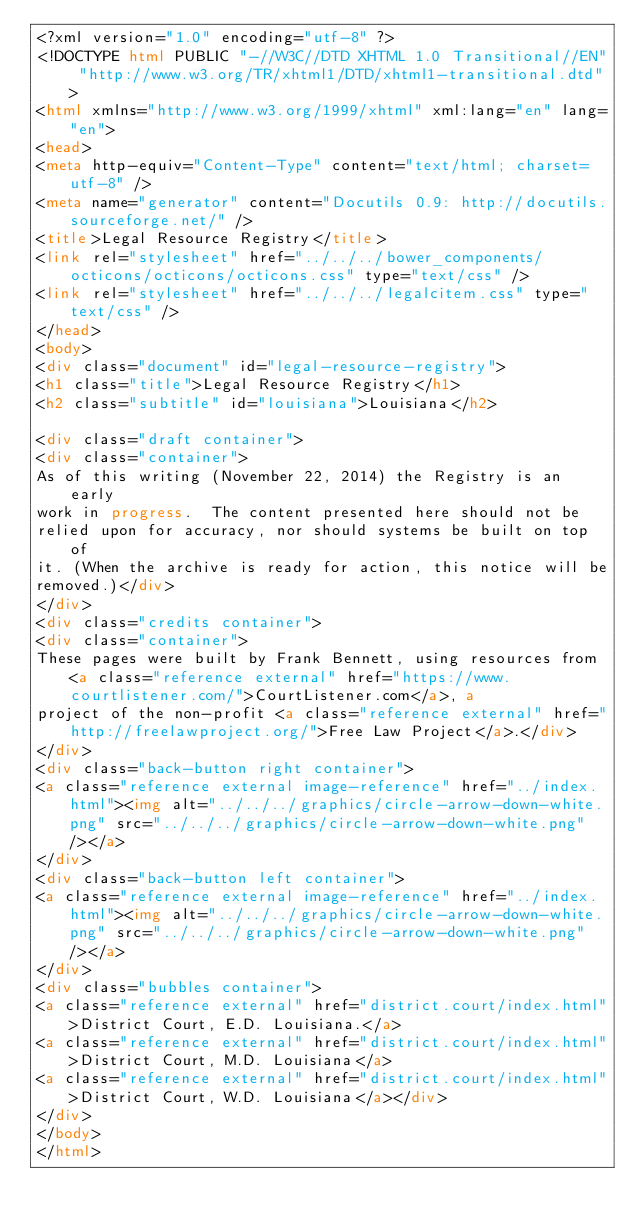<code> <loc_0><loc_0><loc_500><loc_500><_HTML_><?xml version="1.0" encoding="utf-8" ?>
<!DOCTYPE html PUBLIC "-//W3C//DTD XHTML 1.0 Transitional//EN" "http://www.w3.org/TR/xhtml1/DTD/xhtml1-transitional.dtd">
<html xmlns="http://www.w3.org/1999/xhtml" xml:lang="en" lang="en">
<head>
<meta http-equiv="Content-Type" content="text/html; charset=utf-8" />
<meta name="generator" content="Docutils 0.9: http://docutils.sourceforge.net/" />
<title>Legal Resource Registry</title>
<link rel="stylesheet" href="../../../bower_components/octicons/octicons/octicons.css" type="text/css" />
<link rel="stylesheet" href="../../../legalcitem.css" type="text/css" />
</head>
<body>
<div class="document" id="legal-resource-registry">
<h1 class="title">Legal Resource Registry</h1>
<h2 class="subtitle" id="louisiana">Louisiana</h2>

<div class="draft container">
<div class="container">
As of this writing (November 22, 2014) the Registry is an early
work in progress.  The content presented here should not be
relied upon for accuracy, nor should systems be built on top of
it. (When the archive is ready for action, this notice will be
removed.)</div>
</div>
<div class="credits container">
<div class="container">
These pages were built by Frank Bennett, using resources from <a class="reference external" href="https://www.courtlistener.com/">CourtListener.com</a>, a
project of the non-profit <a class="reference external" href="http://freelawproject.org/">Free Law Project</a>.</div>
</div>
<div class="back-button right container">
<a class="reference external image-reference" href="../index.html"><img alt="../../../graphics/circle-arrow-down-white.png" src="../../../graphics/circle-arrow-down-white.png" /></a>
</div>
<div class="back-button left container">
<a class="reference external image-reference" href="../index.html"><img alt="../../../graphics/circle-arrow-down-white.png" src="../../../graphics/circle-arrow-down-white.png" /></a>
</div>
<div class="bubbles container">
<a class="reference external" href="district.court/index.html">District Court, E.D. Louisiana.</a>
<a class="reference external" href="district.court/index.html">District Court, M.D. Louisiana</a>
<a class="reference external" href="district.court/index.html">District Court, W.D. Louisiana</a></div>
</div>
</body>
</html>
</code> 